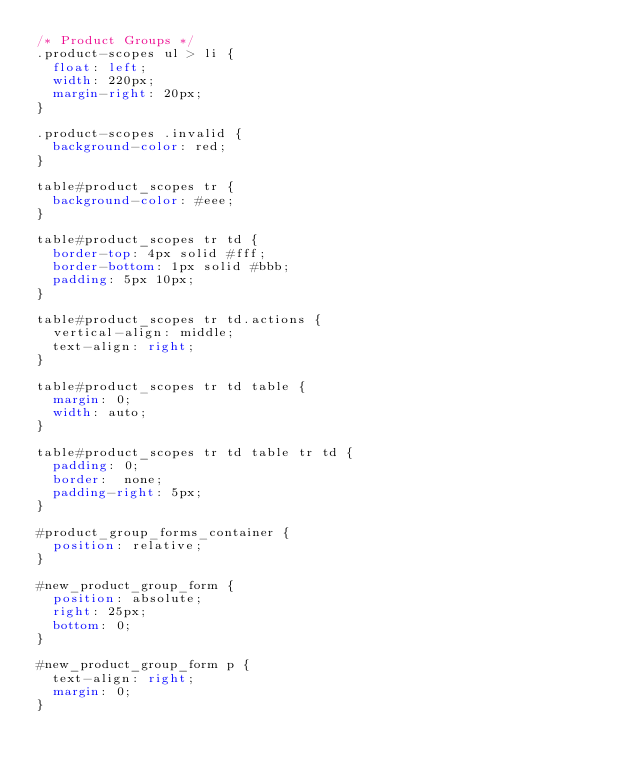Convert code to text. <code><loc_0><loc_0><loc_500><loc_500><_CSS_>/* Product Groups */
.product-scopes ul > li {
  float: left;
  width: 220px;
  margin-right: 20px;
}

.product-scopes .invalid {
  background-color: red;
}

table#product_scopes tr {
  background-color: #eee;
}

table#product_scopes tr td {
  border-top: 4px solid #fff;
  border-bottom: 1px solid #bbb;
  padding: 5px 10px;
}

table#product_scopes tr td.actions {
  vertical-align: middle;
  text-align: right;
}

table#product_scopes tr td table {
  margin: 0;
  width: auto;
}

table#product_scopes tr td table tr td {
  padding: 0;
  border:  none;
  padding-right: 5px;
}

#product_group_forms_container {
  position: relative;
}

#new_product_group_form {
  position: absolute;
  right: 25px;
  bottom: 0;
}

#new_product_group_form p {
  text-align: right;
  margin: 0;
}
</code> 